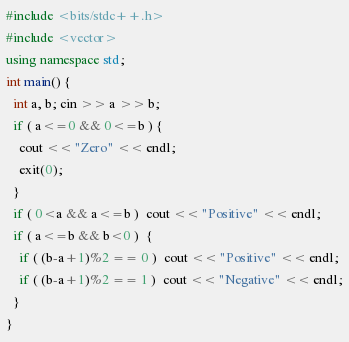Convert code to text. <code><loc_0><loc_0><loc_500><loc_500><_C++_>#include <bits/stdc++.h>
#include <vector>
using namespace std;
int main() {
  int a, b; cin >> a >> b;
  if ( a<=0 && 0<=b ) {
    cout << "Zero" << endl;
    exit(0);
  }
  if ( 0<a && a<=b )  cout << "Positive" << endl;
  if ( a<=b && b<0 )  {
    if ( (b-a+1)%2 == 0 )  cout << "Positive" << endl;
    if ( (b-a+1)%2 == 1 )  cout << "Negative" << endl;
  }
}</code> 